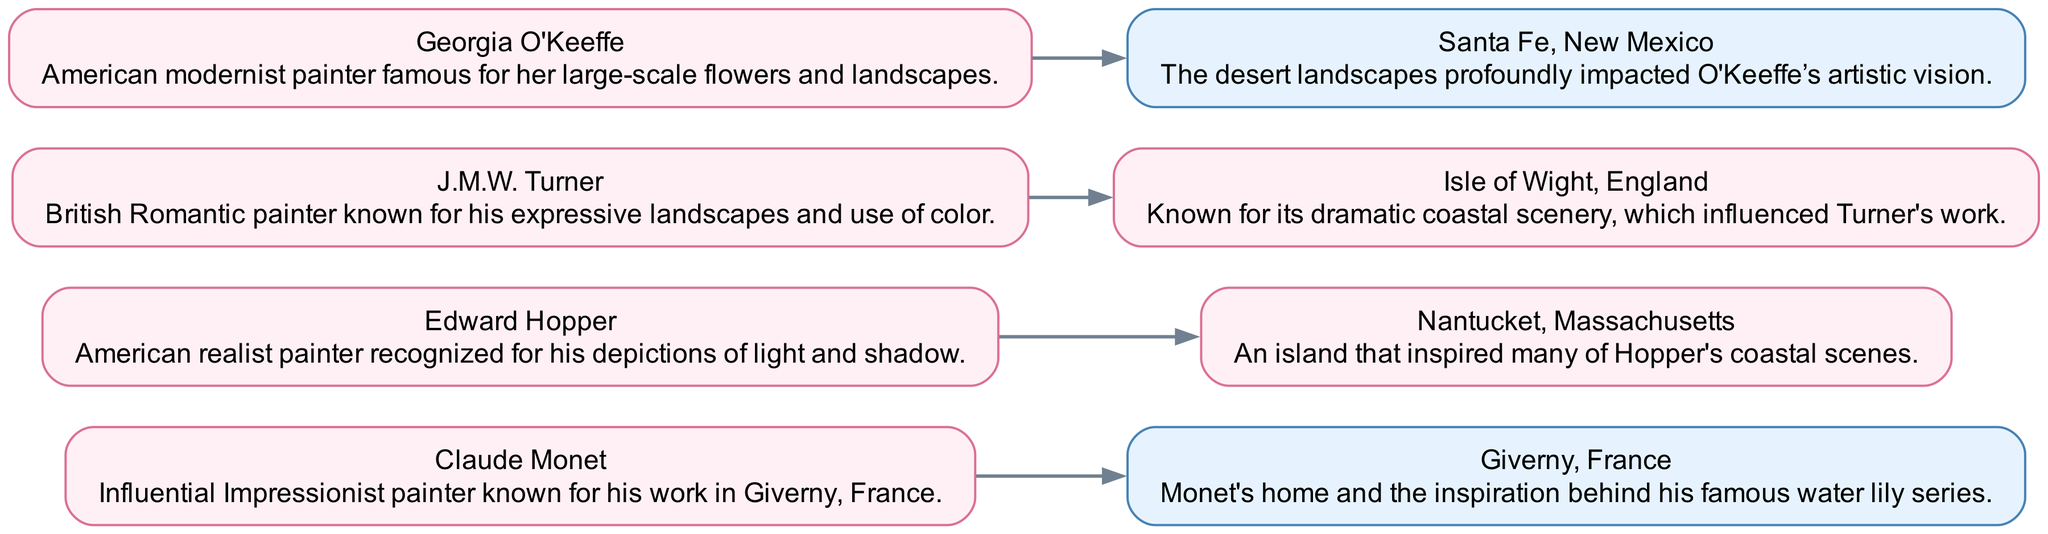What is the total number of nodes in the diagram? The diagram contains a list of nodes that represent influential artists and their associated landscapes. By counting these entries in the nodes section, we find a total of eight artists and locations.
Answer: 8 Which artist is connected to Giverny? In the diagram, we can trace the edge from the node representing Giverny to see which artist it connects to. The edge directly points to Claude Monet, indicating that he is the artist associated with Giverny.
Answer: Claude Monet How many edges are there in total? The edges represent the direct connections between the artists and their landscapes. By counting the edges listed in the edges section, we find four connections present in the diagram.
Answer: 4 Which island is J.M.W. Turner associated with? To find the island connected to J.M.W. Turner, we look for the outgoing edge from his node. The edge leads to the Isle of Wight, indicating this is the island associated with Turner’s work.
Answer: Isle of Wight Are there any American artists in the diagram? By examining the artist nodes, we identify which artists are American. Both Edward Hopper and Georgia O'Keeffe are recognized as American artists, confirming that the diagram contains American influences.
Answer: Yes What type of landscapes influenced Georgia O'Keeffe's work? To answer this, we refer to the edge connecting Georgia O'Keeffe to her associated location. The node Santa Fe indicates that it is the desert landscapes that profoundly impacted O'Keeffe's artistic vision.
Answer: Desert landscapes From which island did Edward Hopper draw inspiration? By tracking the edge from Edward Hopper's node, we see that it points towards Nantucket, which signifies this is the location that inspired his coastal scenes.
Answer: Nantucket What distinguishes the color scheme of the nodes representing islands? In the diagram, nodes representing islands are styled with a specific fill color that is lighter and characterized by a fillcolor of #E6F3FF, differentiating them visually from the artist nodes.
Answer: Lighter color Which artist is associated with large-scale flowers? To find the artist known for large-scale flowers, we look at the description for each artist. Georgia O'Keeffe's description specifically mentions her fame for large-scale flowers, making her the answer.
Answer: Georgia O'Keeffe 